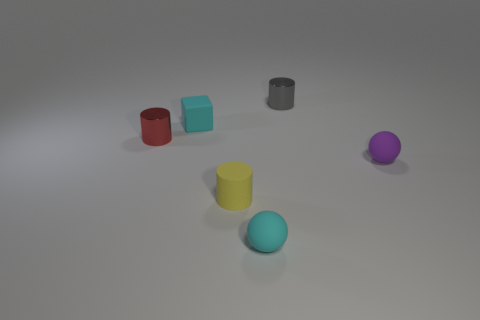Does the small cyan object on the right side of the small yellow matte object have the same material as the object behind the small matte block?
Give a very brief answer. No. Are there any other things that are the same shape as the purple matte thing?
Offer a terse response. Yes. The tiny matte cube is what color?
Offer a terse response. Cyan. How many small cyan objects are the same shape as the small gray metal object?
Provide a short and direct response. 0. There is a shiny cylinder that is the same size as the gray metal thing; what is its color?
Give a very brief answer. Red. Is there a small red thing?
Make the answer very short. Yes. There is a gray metal object behind the purple sphere; what shape is it?
Give a very brief answer. Cylinder. What number of cylinders are behind the tiny purple rubber sphere and in front of the block?
Offer a very short reply. 1. Is there a small purple object made of the same material as the red cylinder?
Offer a terse response. No. What is the size of the thing that is the same color as the small block?
Your response must be concise. Small. 